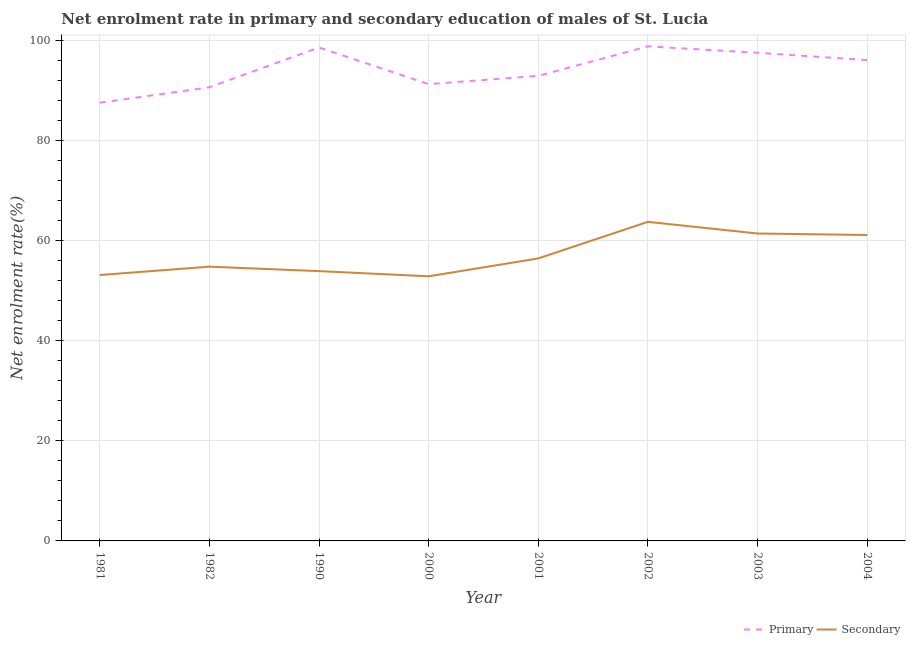Does the line corresponding to enrollment rate in secondary education intersect with the line corresponding to enrollment rate in primary education?
Provide a short and direct response. No. What is the enrollment rate in primary education in 1990?
Your answer should be very brief. 98.68. Across all years, what is the maximum enrollment rate in primary education?
Make the answer very short. 98.9. Across all years, what is the minimum enrollment rate in secondary education?
Offer a very short reply. 52.92. In which year was the enrollment rate in secondary education minimum?
Provide a short and direct response. 2000. What is the total enrollment rate in primary education in the graph?
Offer a terse response. 754.09. What is the difference between the enrollment rate in primary education in 2003 and that in 2004?
Your response must be concise. 1.47. What is the difference between the enrollment rate in secondary education in 2004 and the enrollment rate in primary education in 2002?
Ensure brevity in your answer.  -37.72. What is the average enrollment rate in primary education per year?
Provide a short and direct response. 94.26. In the year 1982, what is the difference between the enrollment rate in secondary education and enrollment rate in primary education?
Give a very brief answer. -35.88. In how many years, is the enrollment rate in secondary education greater than 88 %?
Keep it short and to the point. 0. What is the ratio of the enrollment rate in primary education in 1990 to that in 2001?
Offer a very short reply. 1.06. Is the difference between the enrollment rate in primary education in 2001 and 2003 greater than the difference between the enrollment rate in secondary education in 2001 and 2003?
Keep it short and to the point. Yes. What is the difference between the highest and the second highest enrollment rate in primary education?
Keep it short and to the point. 0.22. What is the difference between the highest and the lowest enrollment rate in primary education?
Keep it short and to the point. 11.27. In how many years, is the enrollment rate in primary education greater than the average enrollment rate in primary education taken over all years?
Your answer should be very brief. 4. Is the sum of the enrollment rate in secondary education in 2000 and 2002 greater than the maximum enrollment rate in primary education across all years?
Your response must be concise. Yes. Does the enrollment rate in primary education monotonically increase over the years?
Provide a succinct answer. No. How many lines are there?
Provide a short and direct response. 2. How many years are there in the graph?
Keep it short and to the point. 8. Are the values on the major ticks of Y-axis written in scientific E-notation?
Make the answer very short. No. Does the graph contain any zero values?
Make the answer very short. No. Does the graph contain grids?
Provide a succinct answer. Yes. Where does the legend appear in the graph?
Your answer should be compact. Bottom right. How are the legend labels stacked?
Your answer should be very brief. Horizontal. What is the title of the graph?
Your answer should be compact. Net enrolment rate in primary and secondary education of males of St. Lucia. What is the label or title of the X-axis?
Provide a short and direct response. Year. What is the label or title of the Y-axis?
Offer a terse response. Net enrolment rate(%). What is the Net enrolment rate(%) of Primary in 1981?
Your answer should be very brief. 87.63. What is the Net enrolment rate(%) of Secondary in 1981?
Give a very brief answer. 53.18. What is the Net enrolment rate(%) in Primary in 1982?
Your answer should be compact. 90.72. What is the Net enrolment rate(%) of Secondary in 1982?
Provide a short and direct response. 54.85. What is the Net enrolment rate(%) of Primary in 1990?
Give a very brief answer. 98.68. What is the Net enrolment rate(%) of Secondary in 1990?
Provide a short and direct response. 53.96. What is the Net enrolment rate(%) of Primary in 2000?
Ensure brevity in your answer.  91.35. What is the Net enrolment rate(%) in Secondary in 2000?
Provide a succinct answer. 52.92. What is the Net enrolment rate(%) in Primary in 2001?
Provide a succinct answer. 93.01. What is the Net enrolment rate(%) of Secondary in 2001?
Your response must be concise. 56.5. What is the Net enrolment rate(%) of Primary in 2002?
Offer a terse response. 98.9. What is the Net enrolment rate(%) of Secondary in 2002?
Offer a very short reply. 63.81. What is the Net enrolment rate(%) of Primary in 2003?
Offer a terse response. 97.63. What is the Net enrolment rate(%) in Secondary in 2003?
Your response must be concise. 61.48. What is the Net enrolment rate(%) of Primary in 2004?
Offer a very short reply. 96.16. What is the Net enrolment rate(%) of Secondary in 2004?
Offer a terse response. 61.18. Across all years, what is the maximum Net enrolment rate(%) of Primary?
Give a very brief answer. 98.9. Across all years, what is the maximum Net enrolment rate(%) in Secondary?
Make the answer very short. 63.81. Across all years, what is the minimum Net enrolment rate(%) in Primary?
Your answer should be very brief. 87.63. Across all years, what is the minimum Net enrolment rate(%) in Secondary?
Provide a succinct answer. 52.92. What is the total Net enrolment rate(%) in Primary in the graph?
Offer a very short reply. 754.1. What is the total Net enrolment rate(%) in Secondary in the graph?
Provide a succinct answer. 457.88. What is the difference between the Net enrolment rate(%) in Primary in 1981 and that in 1982?
Your response must be concise. -3.09. What is the difference between the Net enrolment rate(%) in Secondary in 1981 and that in 1982?
Offer a very short reply. -1.66. What is the difference between the Net enrolment rate(%) in Primary in 1981 and that in 1990?
Keep it short and to the point. -11.05. What is the difference between the Net enrolment rate(%) of Secondary in 1981 and that in 1990?
Provide a short and direct response. -0.78. What is the difference between the Net enrolment rate(%) of Primary in 1981 and that in 2000?
Ensure brevity in your answer.  -3.72. What is the difference between the Net enrolment rate(%) of Secondary in 1981 and that in 2000?
Your answer should be very brief. 0.26. What is the difference between the Net enrolment rate(%) in Primary in 1981 and that in 2001?
Provide a succinct answer. -5.37. What is the difference between the Net enrolment rate(%) of Secondary in 1981 and that in 2001?
Your answer should be very brief. -3.32. What is the difference between the Net enrolment rate(%) of Primary in 1981 and that in 2002?
Your response must be concise. -11.27. What is the difference between the Net enrolment rate(%) in Secondary in 1981 and that in 2002?
Provide a succinct answer. -10.63. What is the difference between the Net enrolment rate(%) in Primary in 1981 and that in 2003?
Offer a terse response. -9.99. What is the difference between the Net enrolment rate(%) in Secondary in 1981 and that in 2003?
Ensure brevity in your answer.  -8.3. What is the difference between the Net enrolment rate(%) in Primary in 1981 and that in 2004?
Give a very brief answer. -8.53. What is the difference between the Net enrolment rate(%) of Secondary in 1981 and that in 2004?
Your answer should be compact. -8. What is the difference between the Net enrolment rate(%) of Primary in 1982 and that in 1990?
Give a very brief answer. -7.96. What is the difference between the Net enrolment rate(%) in Primary in 1982 and that in 2000?
Your answer should be compact. -0.63. What is the difference between the Net enrolment rate(%) of Secondary in 1982 and that in 2000?
Your answer should be very brief. 1.92. What is the difference between the Net enrolment rate(%) of Primary in 1982 and that in 2001?
Provide a succinct answer. -2.28. What is the difference between the Net enrolment rate(%) of Secondary in 1982 and that in 2001?
Keep it short and to the point. -1.65. What is the difference between the Net enrolment rate(%) of Primary in 1982 and that in 2002?
Keep it short and to the point. -8.18. What is the difference between the Net enrolment rate(%) of Secondary in 1982 and that in 2002?
Your response must be concise. -8.97. What is the difference between the Net enrolment rate(%) in Primary in 1982 and that in 2003?
Ensure brevity in your answer.  -6.9. What is the difference between the Net enrolment rate(%) of Secondary in 1982 and that in 2003?
Offer a terse response. -6.63. What is the difference between the Net enrolment rate(%) of Primary in 1982 and that in 2004?
Ensure brevity in your answer.  -5.44. What is the difference between the Net enrolment rate(%) of Secondary in 1982 and that in 2004?
Give a very brief answer. -6.34. What is the difference between the Net enrolment rate(%) of Primary in 1990 and that in 2000?
Your response must be concise. 7.33. What is the difference between the Net enrolment rate(%) in Secondary in 1990 and that in 2000?
Give a very brief answer. 1.03. What is the difference between the Net enrolment rate(%) in Primary in 1990 and that in 2001?
Your answer should be compact. 5.67. What is the difference between the Net enrolment rate(%) in Secondary in 1990 and that in 2001?
Your answer should be very brief. -2.54. What is the difference between the Net enrolment rate(%) in Primary in 1990 and that in 2002?
Your response must be concise. -0.22. What is the difference between the Net enrolment rate(%) of Secondary in 1990 and that in 2002?
Your response must be concise. -9.86. What is the difference between the Net enrolment rate(%) of Primary in 1990 and that in 2003?
Your answer should be compact. 1.05. What is the difference between the Net enrolment rate(%) in Secondary in 1990 and that in 2003?
Offer a terse response. -7.52. What is the difference between the Net enrolment rate(%) of Primary in 1990 and that in 2004?
Provide a succinct answer. 2.52. What is the difference between the Net enrolment rate(%) of Secondary in 1990 and that in 2004?
Offer a terse response. -7.23. What is the difference between the Net enrolment rate(%) of Primary in 2000 and that in 2001?
Ensure brevity in your answer.  -1.66. What is the difference between the Net enrolment rate(%) of Secondary in 2000 and that in 2001?
Your answer should be very brief. -3.57. What is the difference between the Net enrolment rate(%) of Primary in 2000 and that in 2002?
Provide a short and direct response. -7.55. What is the difference between the Net enrolment rate(%) of Secondary in 2000 and that in 2002?
Ensure brevity in your answer.  -10.89. What is the difference between the Net enrolment rate(%) of Primary in 2000 and that in 2003?
Keep it short and to the point. -6.28. What is the difference between the Net enrolment rate(%) in Secondary in 2000 and that in 2003?
Offer a very short reply. -8.56. What is the difference between the Net enrolment rate(%) of Primary in 2000 and that in 2004?
Offer a terse response. -4.81. What is the difference between the Net enrolment rate(%) in Secondary in 2000 and that in 2004?
Make the answer very short. -8.26. What is the difference between the Net enrolment rate(%) in Primary in 2001 and that in 2002?
Offer a very short reply. -5.9. What is the difference between the Net enrolment rate(%) of Secondary in 2001 and that in 2002?
Your answer should be compact. -7.32. What is the difference between the Net enrolment rate(%) of Primary in 2001 and that in 2003?
Make the answer very short. -4.62. What is the difference between the Net enrolment rate(%) in Secondary in 2001 and that in 2003?
Provide a short and direct response. -4.98. What is the difference between the Net enrolment rate(%) of Primary in 2001 and that in 2004?
Your answer should be compact. -3.15. What is the difference between the Net enrolment rate(%) of Secondary in 2001 and that in 2004?
Offer a terse response. -4.68. What is the difference between the Net enrolment rate(%) of Primary in 2002 and that in 2003?
Your response must be concise. 1.28. What is the difference between the Net enrolment rate(%) in Secondary in 2002 and that in 2003?
Your response must be concise. 2.33. What is the difference between the Net enrolment rate(%) in Primary in 2002 and that in 2004?
Your response must be concise. 2.74. What is the difference between the Net enrolment rate(%) of Secondary in 2002 and that in 2004?
Your answer should be very brief. 2.63. What is the difference between the Net enrolment rate(%) in Primary in 2003 and that in 2004?
Offer a terse response. 1.47. What is the difference between the Net enrolment rate(%) in Secondary in 2003 and that in 2004?
Make the answer very short. 0.3. What is the difference between the Net enrolment rate(%) of Primary in 1981 and the Net enrolment rate(%) of Secondary in 1982?
Give a very brief answer. 32.79. What is the difference between the Net enrolment rate(%) in Primary in 1981 and the Net enrolment rate(%) in Secondary in 1990?
Your response must be concise. 33.68. What is the difference between the Net enrolment rate(%) of Primary in 1981 and the Net enrolment rate(%) of Secondary in 2000?
Keep it short and to the point. 34.71. What is the difference between the Net enrolment rate(%) of Primary in 1981 and the Net enrolment rate(%) of Secondary in 2001?
Ensure brevity in your answer.  31.14. What is the difference between the Net enrolment rate(%) in Primary in 1981 and the Net enrolment rate(%) in Secondary in 2002?
Give a very brief answer. 23.82. What is the difference between the Net enrolment rate(%) in Primary in 1981 and the Net enrolment rate(%) in Secondary in 2003?
Your answer should be very brief. 26.16. What is the difference between the Net enrolment rate(%) of Primary in 1981 and the Net enrolment rate(%) of Secondary in 2004?
Your answer should be compact. 26.45. What is the difference between the Net enrolment rate(%) of Primary in 1982 and the Net enrolment rate(%) of Secondary in 1990?
Provide a short and direct response. 36.77. What is the difference between the Net enrolment rate(%) of Primary in 1982 and the Net enrolment rate(%) of Secondary in 2000?
Keep it short and to the point. 37.8. What is the difference between the Net enrolment rate(%) of Primary in 1982 and the Net enrolment rate(%) of Secondary in 2001?
Keep it short and to the point. 34.23. What is the difference between the Net enrolment rate(%) in Primary in 1982 and the Net enrolment rate(%) in Secondary in 2002?
Provide a succinct answer. 26.91. What is the difference between the Net enrolment rate(%) of Primary in 1982 and the Net enrolment rate(%) of Secondary in 2003?
Ensure brevity in your answer.  29.24. What is the difference between the Net enrolment rate(%) of Primary in 1982 and the Net enrolment rate(%) of Secondary in 2004?
Give a very brief answer. 29.54. What is the difference between the Net enrolment rate(%) in Primary in 1990 and the Net enrolment rate(%) in Secondary in 2000?
Your response must be concise. 45.76. What is the difference between the Net enrolment rate(%) in Primary in 1990 and the Net enrolment rate(%) in Secondary in 2001?
Your response must be concise. 42.18. What is the difference between the Net enrolment rate(%) in Primary in 1990 and the Net enrolment rate(%) in Secondary in 2002?
Provide a short and direct response. 34.87. What is the difference between the Net enrolment rate(%) of Primary in 1990 and the Net enrolment rate(%) of Secondary in 2003?
Your answer should be very brief. 37.2. What is the difference between the Net enrolment rate(%) of Primary in 1990 and the Net enrolment rate(%) of Secondary in 2004?
Your response must be concise. 37.5. What is the difference between the Net enrolment rate(%) of Primary in 2000 and the Net enrolment rate(%) of Secondary in 2001?
Give a very brief answer. 34.85. What is the difference between the Net enrolment rate(%) in Primary in 2000 and the Net enrolment rate(%) in Secondary in 2002?
Give a very brief answer. 27.54. What is the difference between the Net enrolment rate(%) of Primary in 2000 and the Net enrolment rate(%) of Secondary in 2003?
Your answer should be compact. 29.87. What is the difference between the Net enrolment rate(%) in Primary in 2000 and the Net enrolment rate(%) in Secondary in 2004?
Keep it short and to the point. 30.17. What is the difference between the Net enrolment rate(%) in Primary in 2001 and the Net enrolment rate(%) in Secondary in 2002?
Make the answer very short. 29.2. What is the difference between the Net enrolment rate(%) in Primary in 2001 and the Net enrolment rate(%) in Secondary in 2003?
Make the answer very short. 31.53. What is the difference between the Net enrolment rate(%) in Primary in 2001 and the Net enrolment rate(%) in Secondary in 2004?
Offer a very short reply. 31.83. What is the difference between the Net enrolment rate(%) of Primary in 2002 and the Net enrolment rate(%) of Secondary in 2003?
Keep it short and to the point. 37.42. What is the difference between the Net enrolment rate(%) of Primary in 2002 and the Net enrolment rate(%) of Secondary in 2004?
Your answer should be very brief. 37.72. What is the difference between the Net enrolment rate(%) of Primary in 2003 and the Net enrolment rate(%) of Secondary in 2004?
Provide a succinct answer. 36.45. What is the average Net enrolment rate(%) of Primary per year?
Keep it short and to the point. 94.26. What is the average Net enrolment rate(%) in Secondary per year?
Keep it short and to the point. 57.23. In the year 1981, what is the difference between the Net enrolment rate(%) in Primary and Net enrolment rate(%) in Secondary?
Provide a succinct answer. 34.45. In the year 1982, what is the difference between the Net enrolment rate(%) of Primary and Net enrolment rate(%) of Secondary?
Offer a terse response. 35.88. In the year 1990, what is the difference between the Net enrolment rate(%) in Primary and Net enrolment rate(%) in Secondary?
Give a very brief answer. 44.73. In the year 2000, what is the difference between the Net enrolment rate(%) of Primary and Net enrolment rate(%) of Secondary?
Ensure brevity in your answer.  38.43. In the year 2001, what is the difference between the Net enrolment rate(%) in Primary and Net enrolment rate(%) in Secondary?
Keep it short and to the point. 36.51. In the year 2002, what is the difference between the Net enrolment rate(%) in Primary and Net enrolment rate(%) in Secondary?
Provide a short and direct response. 35.09. In the year 2003, what is the difference between the Net enrolment rate(%) in Primary and Net enrolment rate(%) in Secondary?
Give a very brief answer. 36.15. In the year 2004, what is the difference between the Net enrolment rate(%) of Primary and Net enrolment rate(%) of Secondary?
Ensure brevity in your answer.  34.98. What is the ratio of the Net enrolment rate(%) of Primary in 1981 to that in 1982?
Provide a short and direct response. 0.97. What is the ratio of the Net enrolment rate(%) in Secondary in 1981 to that in 1982?
Give a very brief answer. 0.97. What is the ratio of the Net enrolment rate(%) of Primary in 1981 to that in 1990?
Make the answer very short. 0.89. What is the ratio of the Net enrolment rate(%) of Secondary in 1981 to that in 1990?
Give a very brief answer. 0.99. What is the ratio of the Net enrolment rate(%) in Primary in 1981 to that in 2000?
Provide a succinct answer. 0.96. What is the ratio of the Net enrolment rate(%) of Primary in 1981 to that in 2001?
Ensure brevity in your answer.  0.94. What is the ratio of the Net enrolment rate(%) in Secondary in 1981 to that in 2001?
Your answer should be very brief. 0.94. What is the ratio of the Net enrolment rate(%) of Primary in 1981 to that in 2002?
Give a very brief answer. 0.89. What is the ratio of the Net enrolment rate(%) in Secondary in 1981 to that in 2002?
Give a very brief answer. 0.83. What is the ratio of the Net enrolment rate(%) of Primary in 1981 to that in 2003?
Your answer should be very brief. 0.9. What is the ratio of the Net enrolment rate(%) in Secondary in 1981 to that in 2003?
Your answer should be compact. 0.86. What is the ratio of the Net enrolment rate(%) in Primary in 1981 to that in 2004?
Offer a terse response. 0.91. What is the ratio of the Net enrolment rate(%) in Secondary in 1981 to that in 2004?
Make the answer very short. 0.87. What is the ratio of the Net enrolment rate(%) in Primary in 1982 to that in 1990?
Your response must be concise. 0.92. What is the ratio of the Net enrolment rate(%) in Secondary in 1982 to that in 1990?
Ensure brevity in your answer.  1.02. What is the ratio of the Net enrolment rate(%) in Primary in 1982 to that in 2000?
Make the answer very short. 0.99. What is the ratio of the Net enrolment rate(%) in Secondary in 1982 to that in 2000?
Offer a very short reply. 1.04. What is the ratio of the Net enrolment rate(%) in Primary in 1982 to that in 2001?
Your response must be concise. 0.98. What is the ratio of the Net enrolment rate(%) of Secondary in 1982 to that in 2001?
Offer a terse response. 0.97. What is the ratio of the Net enrolment rate(%) in Primary in 1982 to that in 2002?
Keep it short and to the point. 0.92. What is the ratio of the Net enrolment rate(%) of Secondary in 1982 to that in 2002?
Your answer should be very brief. 0.86. What is the ratio of the Net enrolment rate(%) in Primary in 1982 to that in 2003?
Your answer should be compact. 0.93. What is the ratio of the Net enrolment rate(%) in Secondary in 1982 to that in 2003?
Offer a terse response. 0.89. What is the ratio of the Net enrolment rate(%) of Primary in 1982 to that in 2004?
Provide a succinct answer. 0.94. What is the ratio of the Net enrolment rate(%) in Secondary in 1982 to that in 2004?
Your response must be concise. 0.9. What is the ratio of the Net enrolment rate(%) of Primary in 1990 to that in 2000?
Offer a terse response. 1.08. What is the ratio of the Net enrolment rate(%) in Secondary in 1990 to that in 2000?
Your answer should be compact. 1.02. What is the ratio of the Net enrolment rate(%) in Primary in 1990 to that in 2001?
Your answer should be very brief. 1.06. What is the ratio of the Net enrolment rate(%) in Secondary in 1990 to that in 2001?
Offer a terse response. 0.95. What is the ratio of the Net enrolment rate(%) of Secondary in 1990 to that in 2002?
Offer a very short reply. 0.85. What is the ratio of the Net enrolment rate(%) in Primary in 1990 to that in 2003?
Make the answer very short. 1.01. What is the ratio of the Net enrolment rate(%) in Secondary in 1990 to that in 2003?
Make the answer very short. 0.88. What is the ratio of the Net enrolment rate(%) of Primary in 1990 to that in 2004?
Keep it short and to the point. 1.03. What is the ratio of the Net enrolment rate(%) of Secondary in 1990 to that in 2004?
Provide a short and direct response. 0.88. What is the ratio of the Net enrolment rate(%) in Primary in 2000 to that in 2001?
Keep it short and to the point. 0.98. What is the ratio of the Net enrolment rate(%) of Secondary in 2000 to that in 2001?
Offer a terse response. 0.94. What is the ratio of the Net enrolment rate(%) in Primary in 2000 to that in 2002?
Give a very brief answer. 0.92. What is the ratio of the Net enrolment rate(%) of Secondary in 2000 to that in 2002?
Ensure brevity in your answer.  0.83. What is the ratio of the Net enrolment rate(%) in Primary in 2000 to that in 2003?
Your response must be concise. 0.94. What is the ratio of the Net enrolment rate(%) in Secondary in 2000 to that in 2003?
Provide a short and direct response. 0.86. What is the ratio of the Net enrolment rate(%) in Secondary in 2000 to that in 2004?
Provide a short and direct response. 0.86. What is the ratio of the Net enrolment rate(%) in Primary in 2001 to that in 2002?
Provide a short and direct response. 0.94. What is the ratio of the Net enrolment rate(%) of Secondary in 2001 to that in 2002?
Keep it short and to the point. 0.89. What is the ratio of the Net enrolment rate(%) of Primary in 2001 to that in 2003?
Provide a succinct answer. 0.95. What is the ratio of the Net enrolment rate(%) of Secondary in 2001 to that in 2003?
Your answer should be very brief. 0.92. What is the ratio of the Net enrolment rate(%) of Primary in 2001 to that in 2004?
Give a very brief answer. 0.97. What is the ratio of the Net enrolment rate(%) in Secondary in 2001 to that in 2004?
Keep it short and to the point. 0.92. What is the ratio of the Net enrolment rate(%) in Primary in 2002 to that in 2003?
Ensure brevity in your answer.  1.01. What is the ratio of the Net enrolment rate(%) of Secondary in 2002 to that in 2003?
Give a very brief answer. 1.04. What is the ratio of the Net enrolment rate(%) of Primary in 2002 to that in 2004?
Ensure brevity in your answer.  1.03. What is the ratio of the Net enrolment rate(%) of Secondary in 2002 to that in 2004?
Keep it short and to the point. 1.04. What is the ratio of the Net enrolment rate(%) in Primary in 2003 to that in 2004?
Your answer should be very brief. 1.02. What is the ratio of the Net enrolment rate(%) in Secondary in 2003 to that in 2004?
Your answer should be compact. 1. What is the difference between the highest and the second highest Net enrolment rate(%) of Primary?
Give a very brief answer. 0.22. What is the difference between the highest and the second highest Net enrolment rate(%) in Secondary?
Provide a succinct answer. 2.33. What is the difference between the highest and the lowest Net enrolment rate(%) of Primary?
Provide a succinct answer. 11.27. What is the difference between the highest and the lowest Net enrolment rate(%) in Secondary?
Ensure brevity in your answer.  10.89. 